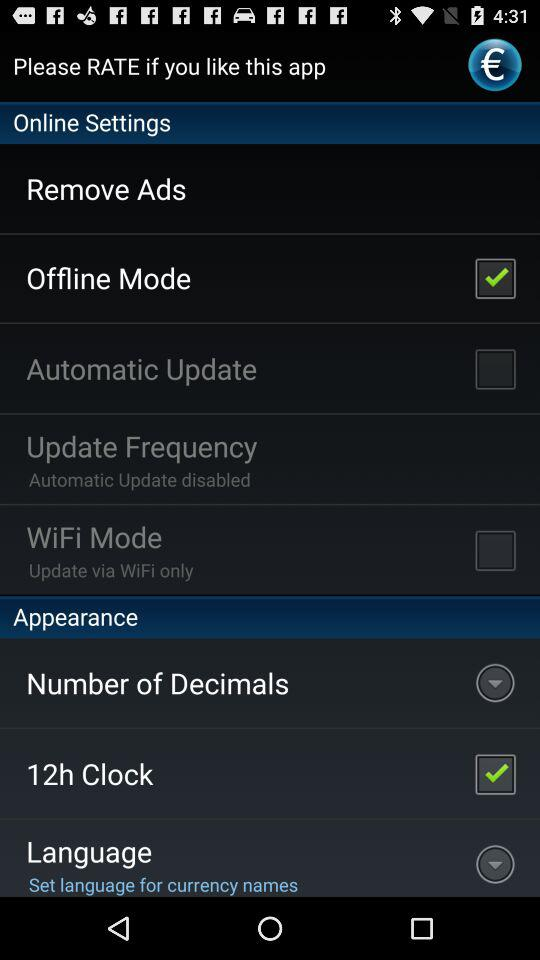How many items are in the Appearance section?
Answer the question using a single word or phrase. 3 